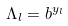<formula> <loc_0><loc_0><loc_500><loc_500>\Lambda _ { l } = b ^ { y _ { l } }</formula> 